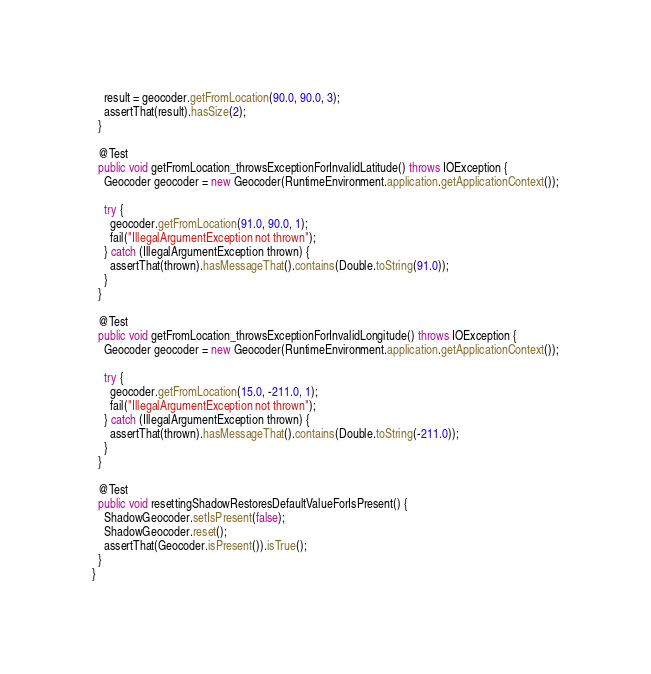<code> <loc_0><loc_0><loc_500><loc_500><_Java_>    result = geocoder.getFromLocation(90.0, 90.0, 3);
    assertThat(result).hasSize(2);
  }

  @Test
  public void getFromLocation_throwsExceptionForInvalidLatitude() throws IOException {
    Geocoder geocoder = new Geocoder(RuntimeEnvironment.application.getApplicationContext());

    try {
      geocoder.getFromLocation(91.0, 90.0, 1);
      fail("IllegalArgumentException not thrown");
    } catch (IllegalArgumentException thrown) {
      assertThat(thrown).hasMessageThat().contains(Double.toString(91.0));
    }
  }

  @Test
  public void getFromLocation_throwsExceptionForInvalidLongitude() throws IOException {
    Geocoder geocoder = new Geocoder(RuntimeEnvironment.application.getApplicationContext());

    try {
      geocoder.getFromLocation(15.0, -211.0, 1);
      fail("IllegalArgumentException not thrown");
    } catch (IllegalArgumentException thrown) {
      assertThat(thrown).hasMessageThat().contains(Double.toString(-211.0));
    }
  }

  @Test
  public void resettingShadowRestoresDefaultValueForIsPresent() {
    ShadowGeocoder.setIsPresent(false);
    ShadowGeocoder.reset();
    assertThat(Geocoder.isPresent()).isTrue();
  }
}
</code> 